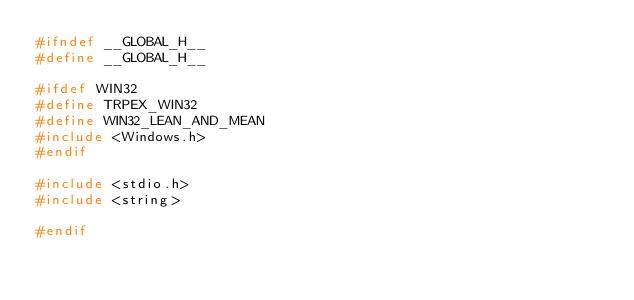Convert code to text. <code><loc_0><loc_0><loc_500><loc_500><_C_>#ifndef __GLOBAL_H__
#define __GLOBAL_H__

#ifdef WIN32
#define TRPEX_WIN32 
#define WIN32_LEAN_AND_MEAN
#include <Windows.h>
#endif

#include <stdio.h>
#include <string>

#endif</code> 